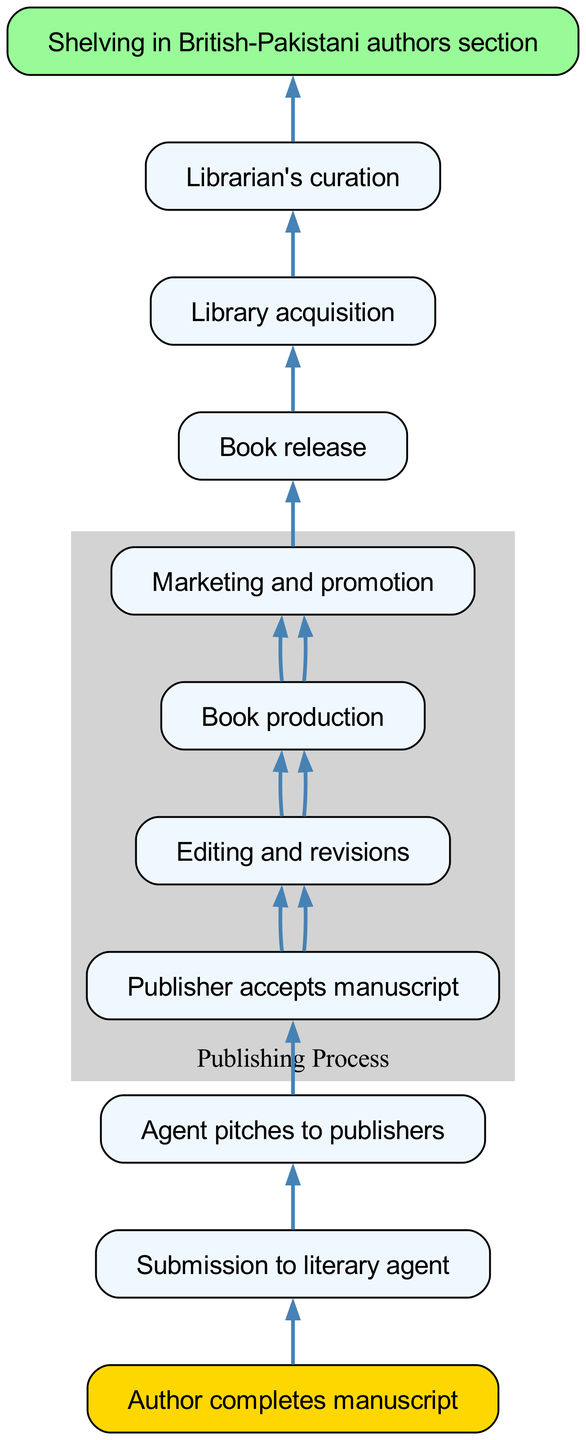What is the first step in the manuscript journey? The first step is represented by the top node in the diagram, which states that the author completes the manuscript.
Answer: Author completes manuscript How many nodes are in the diagram? By counting the individual elements in the 'nodes' list of the data, there are 11 distinct nodes.
Answer: 11 What is the last step in the journey before shelving? The last step before shelving is represented by the node where the librarian curates the book, indicating a quality check or selection process.
Answer: Librarian's curation Which node represents book production? The node that represents book production is connected to the editing and revisions node and transitions to marketing and promotion.
Answer: Book production What is the direct relationship between the author and the library? The direct relationship can be observed through the sequence of nodes: the author submits to a literary agent, which eventually leads to library acquisition.
Answer: Library acquisition Which node is highlighted in gold and what does it signify? The node highlighted in gold is "Author completes manuscript," signifying the starting point of the manuscript journey.
Answer: Author completes manuscript How many edges connect the author directly to the publisher? There are two edges that connect the author to the publisher identifying the submission and acceptance stages of the manuscript journey.
Answer: 2 What process follows marketing and promotion? The process that follows marketing and promotion is the book's release, indicating the transition from preparation to distribution.
Answer: Book release What section of the library are newly added books shelved into? The newly added books are shelved in the British-Pakistani authors section, indicating a specialized collection within the library.
Answer: Shelving in British-Pakistani authors section 